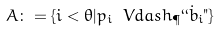<formula> <loc_0><loc_0><loc_500><loc_500>A \colon = \{ i < \theta | p _ { i } \ V d a s h _ { \P } ` ` \dot { b } _ { i } " \}</formula> 